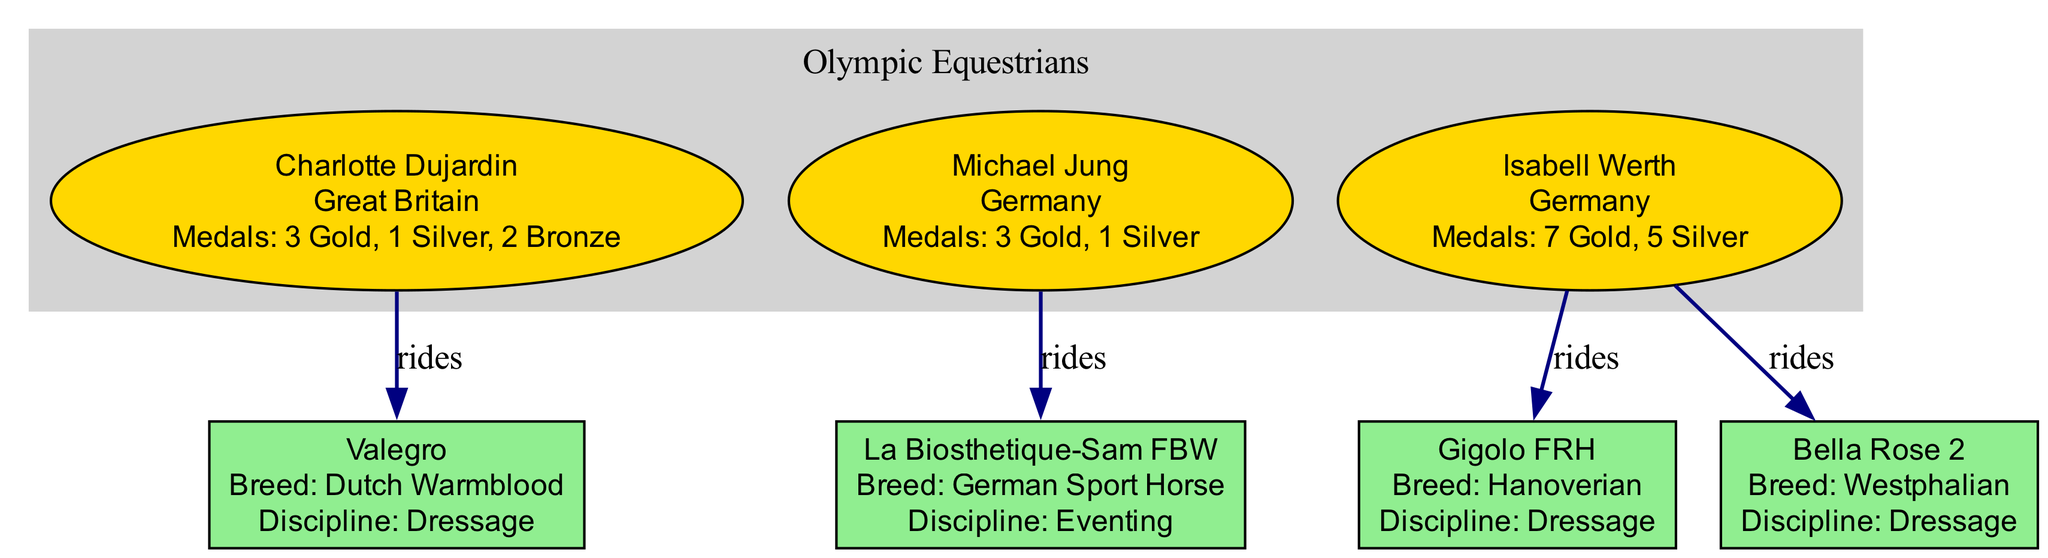What country does Charlotte Dujardin represent? The diagram shows the name of each equestrian alongside their country. For Charlotte Dujardin, the label clearly states "Great Britain".
Answer: Great Britain How many medals does Isabell Werth have? The diagram displays the medal count for each equestrian. Isabell Werth's label indicates that she has "7 Gold, 5 Silver". This implies a total of 12 medals.
Answer: 12 Which horse did Michael Jung ride? The diagram lists the horses associated with each equestrian. Under Michael Jung's label, the horse he rode is "La Biosthetique-Sam FBW".
Answer: La Biosthetique-Sam FBW How many horses does Isabell Werth have listed? By examining the nodes under Isabell Werth’s label, we can see two horses: "Gigolo FRH" and "Bella Rose 2". This indicates that she has more than one horse in the diagram.
Answer: 2 Which equestrian has the highest number of gold medals? By comparing the medal counts in the diagram, Isabell Werth shows the highest count with "7 Gold" compared to other equestrians, making her the top gold medalist.
Answer: Isabell Werth What breed is Valegro? The diagram provides detailed information on each horse, including their breed. Valegro is identified as a "Dutch Warmblood" under its label.
Answer: Dutch Warmblood How many equestrians are represented in the diagram? The diagram displays three distinct equestrians (Charlotte Dujardin, Michael Jung, and Isabell Werth) at the top level. This indicates the total number of equestrians represented.
Answer: 3 What discipline does Gigolo FRH compete in? The diagram lists the discipline for each horse. For Gigolo FRH, the discipline noted is "Dressage".
Answer: Dressage Which horse belongs to Charlotte Dujardin? Looking at Charlotte Dujardin’s part of the diagram, she has a single horse listed, "Valegro", connecting directly to her.
Answer: Valegro 